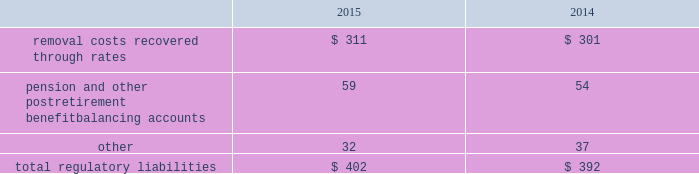The authorized costs of $ 76 are to be recovered via a surcharge over a twenty-year period beginning october 2012 .
Surcharges collected as of december 31 , 2015 and 2014 were $ 4 and $ 5 , respectively .
In addition to the authorized costs , the company expects to incur additional costs totaling $ 34 , which will be recovered from contributions made by the california state coastal conservancy .
Contributions collected as of december 31 , 2015 and 2014 were $ 8 and $ 5 , respectively .
Regulatory balancing accounts accumulate differences between revenues recognized and authorized revenue requirements until they are collected from customers or are refunded .
Regulatory balancing accounts include low income programs and purchased power and water accounts .
Debt expense is amortized over the lives of the respective issues .
Call premiums on the redemption of long- term debt , as well as unamortized debt expense , are deferred and amortized to the extent they will be recovered through future service rates .
Purchase premium recoverable through rates is primarily the recovery of the acquisition premiums related to an asset acquisition by the company 2019s california subsidiary during 2002 , and acquisitions in 2007 by the company 2019s new jersey subsidiary .
As authorized for recovery by the california and new jersey pucs , these costs are being amortized to depreciation and amortization in the consolidated statements of operations through november 2048 .
Tank painting costs are generally deferred and amortized to operations and maintenance expense in the consolidated statements of operations on a straight-line basis over periods ranging from five to fifteen years , as authorized by the regulatory authorities in their determination of rates charged for service .
Other regulatory assets include certain deferred business transformation costs , construction costs for treatment facilities , property tax stabilization , employee-related costs , business services project expenses , coastal water project costs , rate case expenditures and environmental remediation costs among others .
These costs are deferred because the amounts are being recovered in rates or are probable of recovery through rates in future periods .
Regulatory liabilities the regulatory liabilities generally represent probable future reductions in revenues associated with amounts that are to be credited or refunded to customers through the rate-making process .
The table summarizes the composition of regulatory liabilities as of december 31: .
Removal costs recovered through rates are estimated costs to retire assets at the end of their expected useful life that are recovered through customer rates over the life of the associated assets .
In december 2008 , the company 2019s subsidiary in new jersey , at the direction of the new jersey puc , began to depreciate $ 48 of the total balance into depreciation and amortization expense in the consolidated statements of operations via straight line amortization through november 2048 .
Pension and other postretirement benefit balancing accounts represent the difference between costs incurred and costs authorized by the puc 2019s that are expected to be refunded to customers. .
What was the growth rate of the removal costs from 2014 to 2015? 
Rationale: the removal costs grew by 3.3% from 2014 to 2015
Computations: ((311 - 301) / 301)
Answer: 0.03322. 